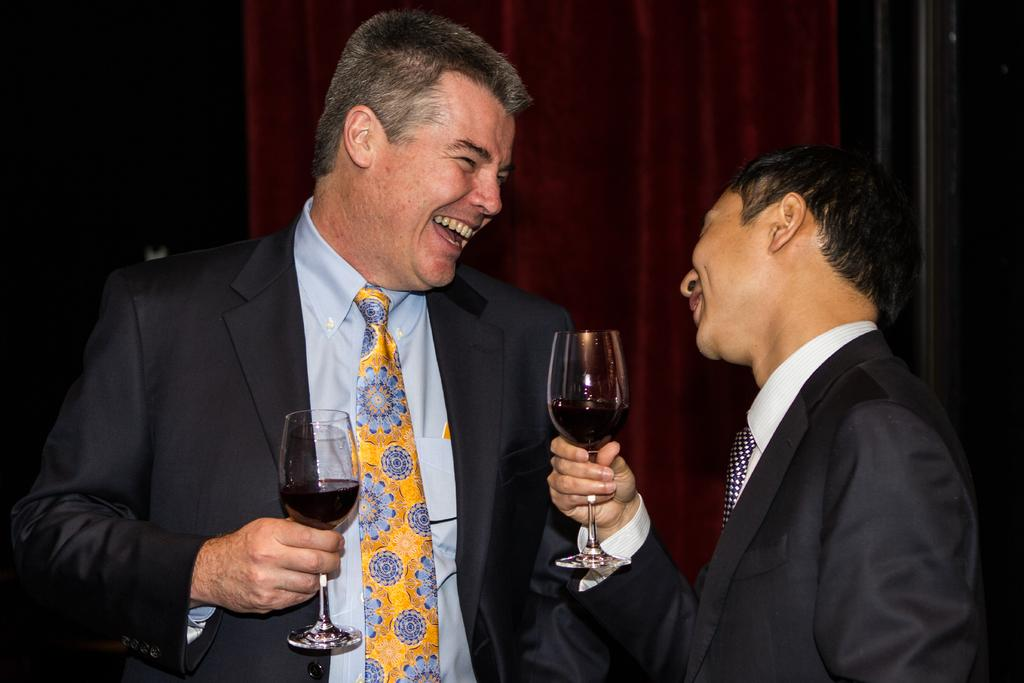How many people are in the image? There are two people in the image. What are the people holding in their hands? The two people are holding glasses in their hands. What is the emotional state of the people in the image? The people are laughing. What type of voice can be heard coming from the farmer in the image? There is no farmer present in the image, so it is not possible to determine what type of voice might be heard. 